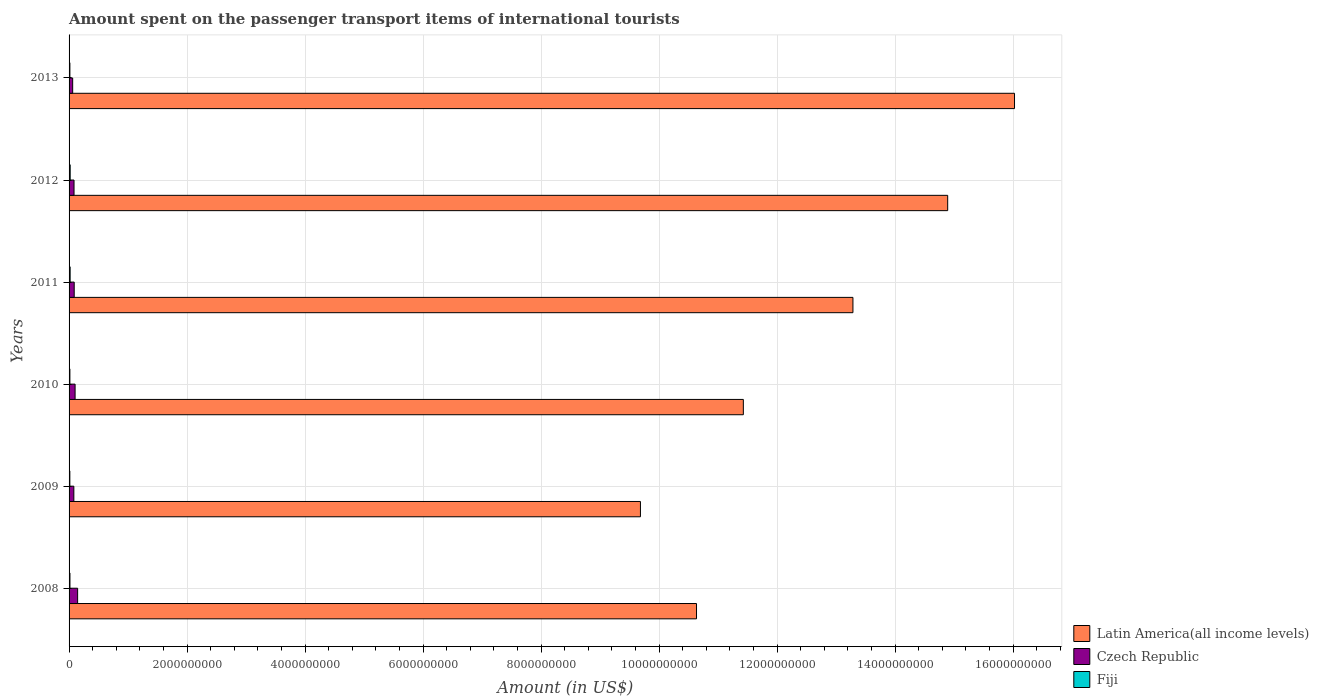How many different coloured bars are there?
Your answer should be compact. 3. How many bars are there on the 4th tick from the bottom?
Ensure brevity in your answer.  3. In how many cases, is the number of bars for a given year not equal to the number of legend labels?
Give a very brief answer. 0. What is the amount spent on the passenger transport items of international tourists in Fiji in 2009?
Offer a very short reply. 1.30e+07. Across all years, what is the maximum amount spent on the passenger transport items of international tourists in Latin America(all income levels)?
Provide a short and direct response. 1.60e+1. Across all years, what is the minimum amount spent on the passenger transport items of international tourists in Czech Republic?
Your answer should be compact. 6.10e+07. In which year was the amount spent on the passenger transport items of international tourists in Latin America(all income levels) maximum?
Your answer should be compact. 2013. What is the total amount spent on the passenger transport items of international tourists in Latin America(all income levels) in the graph?
Keep it short and to the point. 7.60e+1. What is the difference between the amount spent on the passenger transport items of international tourists in Latin America(all income levels) in 2009 and that in 2010?
Ensure brevity in your answer.  -1.74e+09. What is the difference between the amount spent on the passenger transport items of international tourists in Fiji in 2009 and the amount spent on the passenger transport items of international tourists in Czech Republic in 2012?
Provide a succinct answer. -7.10e+07. What is the average amount spent on the passenger transport items of international tourists in Latin America(all income levels) per year?
Offer a very short reply. 1.27e+1. In the year 2012, what is the difference between the amount spent on the passenger transport items of international tourists in Latin America(all income levels) and amount spent on the passenger transport items of international tourists in Fiji?
Your response must be concise. 1.49e+1. In how many years, is the amount spent on the passenger transport items of international tourists in Czech Republic greater than 4000000000 US$?
Provide a short and direct response. 0. What is the ratio of the amount spent on the passenger transport items of international tourists in Latin America(all income levels) in 2008 to that in 2010?
Ensure brevity in your answer.  0.93. Is the difference between the amount spent on the passenger transport items of international tourists in Latin America(all income levels) in 2008 and 2010 greater than the difference between the amount spent on the passenger transport items of international tourists in Fiji in 2008 and 2010?
Give a very brief answer. No. What is the difference between the highest and the second highest amount spent on the passenger transport items of international tourists in Latin America(all income levels)?
Provide a succinct answer. 1.13e+09. What is the difference between the highest and the lowest amount spent on the passenger transport items of international tourists in Latin America(all income levels)?
Your answer should be very brief. 6.34e+09. In how many years, is the amount spent on the passenger transport items of international tourists in Latin America(all income levels) greater than the average amount spent on the passenger transport items of international tourists in Latin America(all income levels) taken over all years?
Provide a succinct answer. 3. What does the 2nd bar from the top in 2012 represents?
Offer a very short reply. Czech Republic. What does the 2nd bar from the bottom in 2012 represents?
Provide a succinct answer. Czech Republic. Is it the case that in every year, the sum of the amount spent on the passenger transport items of international tourists in Latin America(all income levels) and amount spent on the passenger transport items of international tourists in Czech Republic is greater than the amount spent on the passenger transport items of international tourists in Fiji?
Keep it short and to the point. Yes. Are all the bars in the graph horizontal?
Your answer should be compact. Yes. How many years are there in the graph?
Provide a short and direct response. 6. What is the difference between two consecutive major ticks on the X-axis?
Give a very brief answer. 2.00e+09. Are the values on the major ticks of X-axis written in scientific E-notation?
Make the answer very short. No. How are the legend labels stacked?
Your answer should be compact. Vertical. What is the title of the graph?
Ensure brevity in your answer.  Amount spent on the passenger transport items of international tourists. Does "Samoa" appear as one of the legend labels in the graph?
Provide a succinct answer. No. What is the label or title of the X-axis?
Provide a short and direct response. Amount (in US$). What is the label or title of the Y-axis?
Your response must be concise. Years. What is the Amount (in US$) of Latin America(all income levels) in 2008?
Your answer should be compact. 1.06e+1. What is the Amount (in US$) of Czech Republic in 2008?
Offer a terse response. 1.45e+08. What is the Amount (in US$) of Fiji in 2008?
Provide a succinct answer. 1.50e+07. What is the Amount (in US$) in Latin America(all income levels) in 2009?
Make the answer very short. 9.68e+09. What is the Amount (in US$) of Czech Republic in 2009?
Offer a terse response. 8.10e+07. What is the Amount (in US$) in Fiji in 2009?
Make the answer very short. 1.30e+07. What is the Amount (in US$) of Latin America(all income levels) in 2010?
Your answer should be compact. 1.14e+1. What is the Amount (in US$) of Czech Republic in 2010?
Provide a succinct answer. 1.02e+08. What is the Amount (in US$) of Fiji in 2010?
Give a very brief answer. 1.40e+07. What is the Amount (in US$) of Latin America(all income levels) in 2011?
Give a very brief answer. 1.33e+1. What is the Amount (in US$) in Czech Republic in 2011?
Provide a short and direct response. 8.70e+07. What is the Amount (in US$) in Fiji in 2011?
Your answer should be compact. 1.80e+07. What is the Amount (in US$) of Latin America(all income levels) in 2012?
Keep it short and to the point. 1.49e+1. What is the Amount (in US$) in Czech Republic in 2012?
Your answer should be very brief. 8.40e+07. What is the Amount (in US$) in Fiji in 2012?
Your response must be concise. 1.90e+07. What is the Amount (in US$) of Latin America(all income levels) in 2013?
Your response must be concise. 1.60e+1. What is the Amount (in US$) in Czech Republic in 2013?
Offer a terse response. 6.10e+07. What is the Amount (in US$) in Fiji in 2013?
Your response must be concise. 1.40e+07. Across all years, what is the maximum Amount (in US$) of Latin America(all income levels)?
Your answer should be compact. 1.60e+1. Across all years, what is the maximum Amount (in US$) of Czech Republic?
Provide a short and direct response. 1.45e+08. Across all years, what is the maximum Amount (in US$) of Fiji?
Provide a short and direct response. 1.90e+07. Across all years, what is the minimum Amount (in US$) of Latin America(all income levels)?
Your response must be concise. 9.68e+09. Across all years, what is the minimum Amount (in US$) in Czech Republic?
Keep it short and to the point. 6.10e+07. Across all years, what is the minimum Amount (in US$) of Fiji?
Provide a short and direct response. 1.30e+07. What is the total Amount (in US$) in Latin America(all income levels) in the graph?
Give a very brief answer. 7.60e+1. What is the total Amount (in US$) of Czech Republic in the graph?
Give a very brief answer. 5.60e+08. What is the total Amount (in US$) of Fiji in the graph?
Your answer should be compact. 9.30e+07. What is the difference between the Amount (in US$) of Latin America(all income levels) in 2008 and that in 2009?
Provide a succinct answer. 9.51e+08. What is the difference between the Amount (in US$) in Czech Republic in 2008 and that in 2009?
Your response must be concise. 6.40e+07. What is the difference between the Amount (in US$) in Latin America(all income levels) in 2008 and that in 2010?
Your answer should be very brief. -7.94e+08. What is the difference between the Amount (in US$) in Czech Republic in 2008 and that in 2010?
Your answer should be very brief. 4.30e+07. What is the difference between the Amount (in US$) in Latin America(all income levels) in 2008 and that in 2011?
Your response must be concise. -2.65e+09. What is the difference between the Amount (in US$) of Czech Republic in 2008 and that in 2011?
Your response must be concise. 5.80e+07. What is the difference between the Amount (in US$) in Latin America(all income levels) in 2008 and that in 2012?
Offer a terse response. -4.26e+09. What is the difference between the Amount (in US$) of Czech Republic in 2008 and that in 2012?
Provide a short and direct response. 6.10e+07. What is the difference between the Amount (in US$) in Fiji in 2008 and that in 2012?
Keep it short and to the point. -4.00e+06. What is the difference between the Amount (in US$) in Latin America(all income levels) in 2008 and that in 2013?
Offer a terse response. -5.39e+09. What is the difference between the Amount (in US$) in Czech Republic in 2008 and that in 2013?
Provide a succinct answer. 8.40e+07. What is the difference between the Amount (in US$) of Latin America(all income levels) in 2009 and that in 2010?
Your answer should be very brief. -1.74e+09. What is the difference between the Amount (in US$) of Czech Republic in 2009 and that in 2010?
Keep it short and to the point. -2.10e+07. What is the difference between the Amount (in US$) in Fiji in 2009 and that in 2010?
Offer a terse response. -1.00e+06. What is the difference between the Amount (in US$) in Latin America(all income levels) in 2009 and that in 2011?
Offer a very short reply. -3.60e+09. What is the difference between the Amount (in US$) of Czech Republic in 2009 and that in 2011?
Your response must be concise. -6.00e+06. What is the difference between the Amount (in US$) in Fiji in 2009 and that in 2011?
Make the answer very short. -5.00e+06. What is the difference between the Amount (in US$) in Latin America(all income levels) in 2009 and that in 2012?
Keep it short and to the point. -5.21e+09. What is the difference between the Amount (in US$) of Czech Republic in 2009 and that in 2012?
Your answer should be very brief. -3.00e+06. What is the difference between the Amount (in US$) in Fiji in 2009 and that in 2012?
Provide a succinct answer. -6.00e+06. What is the difference between the Amount (in US$) of Latin America(all income levels) in 2009 and that in 2013?
Give a very brief answer. -6.34e+09. What is the difference between the Amount (in US$) of Latin America(all income levels) in 2010 and that in 2011?
Offer a terse response. -1.86e+09. What is the difference between the Amount (in US$) of Czech Republic in 2010 and that in 2011?
Provide a succinct answer. 1.50e+07. What is the difference between the Amount (in US$) of Fiji in 2010 and that in 2011?
Your answer should be compact. -4.00e+06. What is the difference between the Amount (in US$) of Latin America(all income levels) in 2010 and that in 2012?
Provide a short and direct response. -3.46e+09. What is the difference between the Amount (in US$) of Czech Republic in 2010 and that in 2012?
Make the answer very short. 1.80e+07. What is the difference between the Amount (in US$) of Fiji in 2010 and that in 2012?
Make the answer very short. -5.00e+06. What is the difference between the Amount (in US$) in Latin America(all income levels) in 2010 and that in 2013?
Make the answer very short. -4.60e+09. What is the difference between the Amount (in US$) in Czech Republic in 2010 and that in 2013?
Your answer should be compact. 4.10e+07. What is the difference between the Amount (in US$) in Latin America(all income levels) in 2011 and that in 2012?
Provide a succinct answer. -1.61e+09. What is the difference between the Amount (in US$) in Czech Republic in 2011 and that in 2012?
Offer a terse response. 3.00e+06. What is the difference between the Amount (in US$) of Latin America(all income levels) in 2011 and that in 2013?
Your response must be concise. -2.74e+09. What is the difference between the Amount (in US$) in Czech Republic in 2011 and that in 2013?
Give a very brief answer. 2.60e+07. What is the difference between the Amount (in US$) in Latin America(all income levels) in 2012 and that in 2013?
Offer a very short reply. -1.13e+09. What is the difference between the Amount (in US$) in Czech Republic in 2012 and that in 2013?
Offer a terse response. 2.30e+07. What is the difference between the Amount (in US$) in Fiji in 2012 and that in 2013?
Your response must be concise. 5.00e+06. What is the difference between the Amount (in US$) in Latin America(all income levels) in 2008 and the Amount (in US$) in Czech Republic in 2009?
Keep it short and to the point. 1.06e+1. What is the difference between the Amount (in US$) in Latin America(all income levels) in 2008 and the Amount (in US$) in Fiji in 2009?
Make the answer very short. 1.06e+1. What is the difference between the Amount (in US$) in Czech Republic in 2008 and the Amount (in US$) in Fiji in 2009?
Your answer should be very brief. 1.32e+08. What is the difference between the Amount (in US$) in Latin America(all income levels) in 2008 and the Amount (in US$) in Czech Republic in 2010?
Your answer should be compact. 1.05e+1. What is the difference between the Amount (in US$) in Latin America(all income levels) in 2008 and the Amount (in US$) in Fiji in 2010?
Offer a very short reply. 1.06e+1. What is the difference between the Amount (in US$) of Czech Republic in 2008 and the Amount (in US$) of Fiji in 2010?
Provide a succinct answer. 1.31e+08. What is the difference between the Amount (in US$) of Latin America(all income levels) in 2008 and the Amount (in US$) of Czech Republic in 2011?
Your response must be concise. 1.05e+1. What is the difference between the Amount (in US$) of Latin America(all income levels) in 2008 and the Amount (in US$) of Fiji in 2011?
Keep it short and to the point. 1.06e+1. What is the difference between the Amount (in US$) of Czech Republic in 2008 and the Amount (in US$) of Fiji in 2011?
Ensure brevity in your answer.  1.27e+08. What is the difference between the Amount (in US$) in Latin America(all income levels) in 2008 and the Amount (in US$) in Czech Republic in 2012?
Ensure brevity in your answer.  1.06e+1. What is the difference between the Amount (in US$) of Latin America(all income levels) in 2008 and the Amount (in US$) of Fiji in 2012?
Your answer should be compact. 1.06e+1. What is the difference between the Amount (in US$) in Czech Republic in 2008 and the Amount (in US$) in Fiji in 2012?
Give a very brief answer. 1.26e+08. What is the difference between the Amount (in US$) in Latin America(all income levels) in 2008 and the Amount (in US$) in Czech Republic in 2013?
Offer a terse response. 1.06e+1. What is the difference between the Amount (in US$) in Latin America(all income levels) in 2008 and the Amount (in US$) in Fiji in 2013?
Your answer should be very brief. 1.06e+1. What is the difference between the Amount (in US$) of Czech Republic in 2008 and the Amount (in US$) of Fiji in 2013?
Offer a terse response. 1.31e+08. What is the difference between the Amount (in US$) of Latin America(all income levels) in 2009 and the Amount (in US$) of Czech Republic in 2010?
Keep it short and to the point. 9.58e+09. What is the difference between the Amount (in US$) of Latin America(all income levels) in 2009 and the Amount (in US$) of Fiji in 2010?
Offer a terse response. 9.67e+09. What is the difference between the Amount (in US$) in Czech Republic in 2009 and the Amount (in US$) in Fiji in 2010?
Offer a terse response. 6.70e+07. What is the difference between the Amount (in US$) of Latin America(all income levels) in 2009 and the Amount (in US$) of Czech Republic in 2011?
Make the answer very short. 9.60e+09. What is the difference between the Amount (in US$) in Latin America(all income levels) in 2009 and the Amount (in US$) in Fiji in 2011?
Provide a succinct answer. 9.67e+09. What is the difference between the Amount (in US$) in Czech Republic in 2009 and the Amount (in US$) in Fiji in 2011?
Provide a short and direct response. 6.30e+07. What is the difference between the Amount (in US$) in Latin America(all income levels) in 2009 and the Amount (in US$) in Czech Republic in 2012?
Provide a succinct answer. 9.60e+09. What is the difference between the Amount (in US$) of Latin America(all income levels) in 2009 and the Amount (in US$) of Fiji in 2012?
Your answer should be very brief. 9.67e+09. What is the difference between the Amount (in US$) in Czech Republic in 2009 and the Amount (in US$) in Fiji in 2012?
Make the answer very short. 6.20e+07. What is the difference between the Amount (in US$) of Latin America(all income levels) in 2009 and the Amount (in US$) of Czech Republic in 2013?
Make the answer very short. 9.62e+09. What is the difference between the Amount (in US$) in Latin America(all income levels) in 2009 and the Amount (in US$) in Fiji in 2013?
Keep it short and to the point. 9.67e+09. What is the difference between the Amount (in US$) of Czech Republic in 2009 and the Amount (in US$) of Fiji in 2013?
Give a very brief answer. 6.70e+07. What is the difference between the Amount (in US$) of Latin America(all income levels) in 2010 and the Amount (in US$) of Czech Republic in 2011?
Provide a short and direct response. 1.13e+1. What is the difference between the Amount (in US$) of Latin America(all income levels) in 2010 and the Amount (in US$) of Fiji in 2011?
Provide a succinct answer. 1.14e+1. What is the difference between the Amount (in US$) of Czech Republic in 2010 and the Amount (in US$) of Fiji in 2011?
Your response must be concise. 8.40e+07. What is the difference between the Amount (in US$) in Latin America(all income levels) in 2010 and the Amount (in US$) in Czech Republic in 2012?
Provide a short and direct response. 1.13e+1. What is the difference between the Amount (in US$) of Latin America(all income levels) in 2010 and the Amount (in US$) of Fiji in 2012?
Your response must be concise. 1.14e+1. What is the difference between the Amount (in US$) of Czech Republic in 2010 and the Amount (in US$) of Fiji in 2012?
Your response must be concise. 8.30e+07. What is the difference between the Amount (in US$) in Latin America(all income levels) in 2010 and the Amount (in US$) in Czech Republic in 2013?
Your response must be concise. 1.14e+1. What is the difference between the Amount (in US$) in Latin America(all income levels) in 2010 and the Amount (in US$) in Fiji in 2013?
Keep it short and to the point. 1.14e+1. What is the difference between the Amount (in US$) in Czech Republic in 2010 and the Amount (in US$) in Fiji in 2013?
Keep it short and to the point. 8.80e+07. What is the difference between the Amount (in US$) of Latin America(all income levels) in 2011 and the Amount (in US$) of Czech Republic in 2012?
Ensure brevity in your answer.  1.32e+1. What is the difference between the Amount (in US$) of Latin America(all income levels) in 2011 and the Amount (in US$) of Fiji in 2012?
Offer a terse response. 1.33e+1. What is the difference between the Amount (in US$) of Czech Republic in 2011 and the Amount (in US$) of Fiji in 2012?
Provide a short and direct response. 6.80e+07. What is the difference between the Amount (in US$) of Latin America(all income levels) in 2011 and the Amount (in US$) of Czech Republic in 2013?
Ensure brevity in your answer.  1.32e+1. What is the difference between the Amount (in US$) in Latin America(all income levels) in 2011 and the Amount (in US$) in Fiji in 2013?
Offer a terse response. 1.33e+1. What is the difference between the Amount (in US$) of Czech Republic in 2011 and the Amount (in US$) of Fiji in 2013?
Offer a very short reply. 7.30e+07. What is the difference between the Amount (in US$) of Latin America(all income levels) in 2012 and the Amount (in US$) of Czech Republic in 2013?
Your answer should be very brief. 1.48e+1. What is the difference between the Amount (in US$) in Latin America(all income levels) in 2012 and the Amount (in US$) in Fiji in 2013?
Provide a short and direct response. 1.49e+1. What is the difference between the Amount (in US$) in Czech Republic in 2012 and the Amount (in US$) in Fiji in 2013?
Give a very brief answer. 7.00e+07. What is the average Amount (in US$) in Latin America(all income levels) per year?
Offer a terse response. 1.27e+1. What is the average Amount (in US$) of Czech Republic per year?
Your answer should be very brief. 9.33e+07. What is the average Amount (in US$) in Fiji per year?
Provide a succinct answer. 1.55e+07. In the year 2008, what is the difference between the Amount (in US$) in Latin America(all income levels) and Amount (in US$) in Czech Republic?
Offer a very short reply. 1.05e+1. In the year 2008, what is the difference between the Amount (in US$) of Latin America(all income levels) and Amount (in US$) of Fiji?
Your response must be concise. 1.06e+1. In the year 2008, what is the difference between the Amount (in US$) of Czech Republic and Amount (in US$) of Fiji?
Your answer should be very brief. 1.30e+08. In the year 2009, what is the difference between the Amount (in US$) of Latin America(all income levels) and Amount (in US$) of Czech Republic?
Offer a terse response. 9.60e+09. In the year 2009, what is the difference between the Amount (in US$) of Latin America(all income levels) and Amount (in US$) of Fiji?
Give a very brief answer. 9.67e+09. In the year 2009, what is the difference between the Amount (in US$) of Czech Republic and Amount (in US$) of Fiji?
Offer a very short reply. 6.80e+07. In the year 2010, what is the difference between the Amount (in US$) of Latin America(all income levels) and Amount (in US$) of Czech Republic?
Your response must be concise. 1.13e+1. In the year 2010, what is the difference between the Amount (in US$) of Latin America(all income levels) and Amount (in US$) of Fiji?
Ensure brevity in your answer.  1.14e+1. In the year 2010, what is the difference between the Amount (in US$) of Czech Republic and Amount (in US$) of Fiji?
Your answer should be compact. 8.80e+07. In the year 2011, what is the difference between the Amount (in US$) in Latin America(all income levels) and Amount (in US$) in Czech Republic?
Ensure brevity in your answer.  1.32e+1. In the year 2011, what is the difference between the Amount (in US$) of Latin America(all income levels) and Amount (in US$) of Fiji?
Give a very brief answer. 1.33e+1. In the year 2011, what is the difference between the Amount (in US$) in Czech Republic and Amount (in US$) in Fiji?
Your answer should be very brief. 6.90e+07. In the year 2012, what is the difference between the Amount (in US$) in Latin America(all income levels) and Amount (in US$) in Czech Republic?
Your answer should be compact. 1.48e+1. In the year 2012, what is the difference between the Amount (in US$) in Latin America(all income levels) and Amount (in US$) in Fiji?
Provide a short and direct response. 1.49e+1. In the year 2012, what is the difference between the Amount (in US$) of Czech Republic and Amount (in US$) of Fiji?
Your response must be concise. 6.50e+07. In the year 2013, what is the difference between the Amount (in US$) in Latin America(all income levels) and Amount (in US$) in Czech Republic?
Ensure brevity in your answer.  1.60e+1. In the year 2013, what is the difference between the Amount (in US$) of Latin America(all income levels) and Amount (in US$) of Fiji?
Offer a terse response. 1.60e+1. In the year 2013, what is the difference between the Amount (in US$) of Czech Republic and Amount (in US$) of Fiji?
Ensure brevity in your answer.  4.70e+07. What is the ratio of the Amount (in US$) of Latin America(all income levels) in 2008 to that in 2009?
Your answer should be very brief. 1.1. What is the ratio of the Amount (in US$) of Czech Republic in 2008 to that in 2009?
Ensure brevity in your answer.  1.79. What is the ratio of the Amount (in US$) of Fiji in 2008 to that in 2009?
Give a very brief answer. 1.15. What is the ratio of the Amount (in US$) of Latin America(all income levels) in 2008 to that in 2010?
Provide a short and direct response. 0.93. What is the ratio of the Amount (in US$) in Czech Republic in 2008 to that in 2010?
Make the answer very short. 1.42. What is the ratio of the Amount (in US$) in Fiji in 2008 to that in 2010?
Your answer should be very brief. 1.07. What is the ratio of the Amount (in US$) in Latin America(all income levels) in 2008 to that in 2011?
Your response must be concise. 0.8. What is the ratio of the Amount (in US$) in Czech Republic in 2008 to that in 2011?
Ensure brevity in your answer.  1.67. What is the ratio of the Amount (in US$) in Fiji in 2008 to that in 2011?
Your answer should be very brief. 0.83. What is the ratio of the Amount (in US$) of Latin America(all income levels) in 2008 to that in 2012?
Keep it short and to the point. 0.71. What is the ratio of the Amount (in US$) in Czech Republic in 2008 to that in 2012?
Your response must be concise. 1.73. What is the ratio of the Amount (in US$) of Fiji in 2008 to that in 2012?
Offer a terse response. 0.79. What is the ratio of the Amount (in US$) in Latin America(all income levels) in 2008 to that in 2013?
Provide a succinct answer. 0.66. What is the ratio of the Amount (in US$) in Czech Republic in 2008 to that in 2013?
Provide a succinct answer. 2.38. What is the ratio of the Amount (in US$) of Fiji in 2008 to that in 2013?
Offer a very short reply. 1.07. What is the ratio of the Amount (in US$) in Latin America(all income levels) in 2009 to that in 2010?
Give a very brief answer. 0.85. What is the ratio of the Amount (in US$) in Czech Republic in 2009 to that in 2010?
Offer a terse response. 0.79. What is the ratio of the Amount (in US$) in Latin America(all income levels) in 2009 to that in 2011?
Give a very brief answer. 0.73. What is the ratio of the Amount (in US$) of Fiji in 2009 to that in 2011?
Offer a terse response. 0.72. What is the ratio of the Amount (in US$) in Latin America(all income levels) in 2009 to that in 2012?
Your answer should be compact. 0.65. What is the ratio of the Amount (in US$) of Fiji in 2009 to that in 2012?
Ensure brevity in your answer.  0.68. What is the ratio of the Amount (in US$) of Latin America(all income levels) in 2009 to that in 2013?
Offer a terse response. 0.6. What is the ratio of the Amount (in US$) in Czech Republic in 2009 to that in 2013?
Keep it short and to the point. 1.33. What is the ratio of the Amount (in US$) in Fiji in 2009 to that in 2013?
Ensure brevity in your answer.  0.93. What is the ratio of the Amount (in US$) of Latin America(all income levels) in 2010 to that in 2011?
Provide a succinct answer. 0.86. What is the ratio of the Amount (in US$) of Czech Republic in 2010 to that in 2011?
Your response must be concise. 1.17. What is the ratio of the Amount (in US$) of Fiji in 2010 to that in 2011?
Offer a terse response. 0.78. What is the ratio of the Amount (in US$) of Latin America(all income levels) in 2010 to that in 2012?
Ensure brevity in your answer.  0.77. What is the ratio of the Amount (in US$) in Czech Republic in 2010 to that in 2012?
Make the answer very short. 1.21. What is the ratio of the Amount (in US$) in Fiji in 2010 to that in 2012?
Make the answer very short. 0.74. What is the ratio of the Amount (in US$) in Latin America(all income levels) in 2010 to that in 2013?
Ensure brevity in your answer.  0.71. What is the ratio of the Amount (in US$) in Czech Republic in 2010 to that in 2013?
Your response must be concise. 1.67. What is the ratio of the Amount (in US$) of Latin America(all income levels) in 2011 to that in 2012?
Your response must be concise. 0.89. What is the ratio of the Amount (in US$) in Czech Republic in 2011 to that in 2012?
Your answer should be compact. 1.04. What is the ratio of the Amount (in US$) in Fiji in 2011 to that in 2012?
Your answer should be compact. 0.95. What is the ratio of the Amount (in US$) in Latin America(all income levels) in 2011 to that in 2013?
Give a very brief answer. 0.83. What is the ratio of the Amount (in US$) in Czech Republic in 2011 to that in 2013?
Provide a short and direct response. 1.43. What is the ratio of the Amount (in US$) in Latin America(all income levels) in 2012 to that in 2013?
Offer a terse response. 0.93. What is the ratio of the Amount (in US$) in Czech Republic in 2012 to that in 2013?
Provide a short and direct response. 1.38. What is the ratio of the Amount (in US$) in Fiji in 2012 to that in 2013?
Your answer should be compact. 1.36. What is the difference between the highest and the second highest Amount (in US$) in Latin America(all income levels)?
Ensure brevity in your answer.  1.13e+09. What is the difference between the highest and the second highest Amount (in US$) of Czech Republic?
Give a very brief answer. 4.30e+07. What is the difference between the highest and the second highest Amount (in US$) of Fiji?
Provide a succinct answer. 1.00e+06. What is the difference between the highest and the lowest Amount (in US$) in Latin America(all income levels)?
Ensure brevity in your answer.  6.34e+09. What is the difference between the highest and the lowest Amount (in US$) in Czech Republic?
Your answer should be compact. 8.40e+07. What is the difference between the highest and the lowest Amount (in US$) of Fiji?
Make the answer very short. 6.00e+06. 